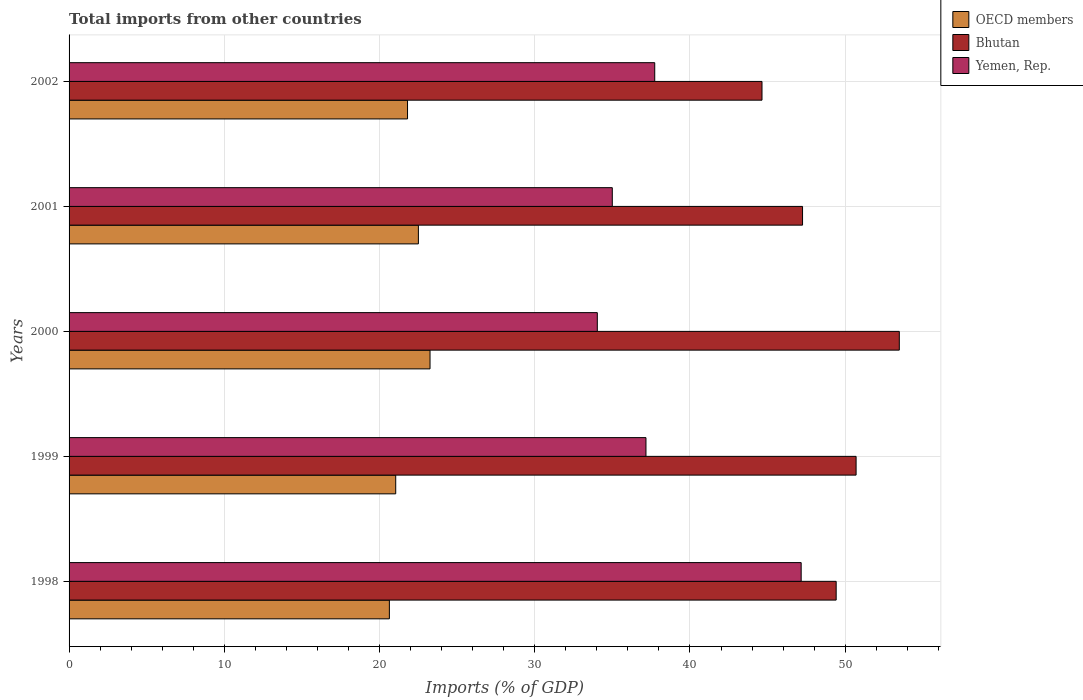Are the number of bars per tick equal to the number of legend labels?
Your answer should be very brief. Yes. How many bars are there on the 1st tick from the top?
Provide a succinct answer. 3. What is the label of the 4th group of bars from the top?
Offer a terse response. 1999. In how many cases, is the number of bars for a given year not equal to the number of legend labels?
Ensure brevity in your answer.  0. What is the total imports in OECD members in 1998?
Keep it short and to the point. 20.63. Across all years, what is the maximum total imports in Yemen, Rep.?
Your answer should be very brief. 47.16. Across all years, what is the minimum total imports in Bhutan?
Give a very brief answer. 44.64. In which year was the total imports in OECD members minimum?
Your answer should be very brief. 1998. What is the total total imports in OECD members in the graph?
Your response must be concise. 109.24. What is the difference between the total imports in OECD members in 1999 and that in 2001?
Make the answer very short. -1.46. What is the difference between the total imports in Bhutan in 1998 and the total imports in OECD members in 1999?
Offer a very short reply. 28.37. What is the average total imports in Yemen, Rep. per year?
Keep it short and to the point. 38.22. In the year 2001, what is the difference between the total imports in OECD members and total imports in Yemen, Rep.?
Your answer should be very brief. -12.49. What is the ratio of the total imports in Bhutan in 1999 to that in 2001?
Provide a short and direct response. 1.07. What is the difference between the highest and the second highest total imports in Bhutan?
Keep it short and to the point. 2.78. What is the difference between the highest and the lowest total imports in Bhutan?
Your answer should be very brief. 8.85. In how many years, is the total imports in Bhutan greater than the average total imports in Bhutan taken over all years?
Provide a succinct answer. 3. Is the sum of the total imports in Bhutan in 1998 and 1999 greater than the maximum total imports in Yemen, Rep. across all years?
Give a very brief answer. Yes. What does the 1st bar from the top in 1999 represents?
Provide a short and direct response. Yemen, Rep. What does the 2nd bar from the bottom in 2002 represents?
Your response must be concise. Bhutan. How many bars are there?
Your response must be concise. 15. Are all the bars in the graph horizontal?
Your response must be concise. Yes. How many years are there in the graph?
Offer a very short reply. 5. What is the difference between two consecutive major ticks on the X-axis?
Offer a terse response. 10. Does the graph contain any zero values?
Provide a succinct answer. No. Does the graph contain grids?
Offer a very short reply. Yes. How many legend labels are there?
Make the answer very short. 3. What is the title of the graph?
Provide a succinct answer. Total imports from other countries. What is the label or title of the X-axis?
Offer a terse response. Imports (% of GDP). What is the label or title of the Y-axis?
Offer a very short reply. Years. What is the Imports (% of GDP) of OECD members in 1998?
Provide a short and direct response. 20.63. What is the Imports (% of GDP) of Bhutan in 1998?
Give a very brief answer. 49.42. What is the Imports (% of GDP) of Yemen, Rep. in 1998?
Your response must be concise. 47.16. What is the Imports (% of GDP) of OECD members in 1999?
Make the answer very short. 21.04. What is the Imports (% of GDP) of Bhutan in 1999?
Make the answer very short. 50.7. What is the Imports (% of GDP) in Yemen, Rep. in 1999?
Make the answer very short. 37.16. What is the Imports (% of GDP) in OECD members in 2000?
Your answer should be very brief. 23.25. What is the Imports (% of GDP) of Bhutan in 2000?
Keep it short and to the point. 53.48. What is the Imports (% of GDP) in Yemen, Rep. in 2000?
Your answer should be very brief. 34.03. What is the Imports (% of GDP) of OECD members in 2001?
Provide a short and direct response. 22.5. What is the Imports (% of GDP) in Bhutan in 2001?
Make the answer very short. 47.25. What is the Imports (% of GDP) of Yemen, Rep. in 2001?
Your answer should be very brief. 35. What is the Imports (% of GDP) of OECD members in 2002?
Your response must be concise. 21.8. What is the Imports (% of GDP) of Bhutan in 2002?
Provide a short and direct response. 44.64. What is the Imports (% of GDP) in Yemen, Rep. in 2002?
Your answer should be very brief. 37.73. Across all years, what is the maximum Imports (% of GDP) in OECD members?
Provide a succinct answer. 23.25. Across all years, what is the maximum Imports (% of GDP) of Bhutan?
Your answer should be very brief. 53.48. Across all years, what is the maximum Imports (% of GDP) in Yemen, Rep.?
Provide a succinct answer. 47.16. Across all years, what is the minimum Imports (% of GDP) of OECD members?
Offer a very short reply. 20.63. Across all years, what is the minimum Imports (% of GDP) in Bhutan?
Provide a succinct answer. 44.64. Across all years, what is the minimum Imports (% of GDP) in Yemen, Rep.?
Make the answer very short. 34.03. What is the total Imports (% of GDP) in OECD members in the graph?
Your answer should be compact. 109.24. What is the total Imports (% of GDP) in Bhutan in the graph?
Make the answer very short. 245.49. What is the total Imports (% of GDP) in Yemen, Rep. in the graph?
Give a very brief answer. 191.08. What is the difference between the Imports (% of GDP) of OECD members in 1998 and that in 1999?
Your answer should be very brief. -0.41. What is the difference between the Imports (% of GDP) of Bhutan in 1998 and that in 1999?
Give a very brief answer. -1.28. What is the difference between the Imports (% of GDP) in Yemen, Rep. in 1998 and that in 1999?
Provide a succinct answer. 10. What is the difference between the Imports (% of GDP) of OECD members in 1998 and that in 2000?
Your response must be concise. -2.62. What is the difference between the Imports (% of GDP) of Bhutan in 1998 and that in 2000?
Your answer should be very brief. -4.07. What is the difference between the Imports (% of GDP) in Yemen, Rep. in 1998 and that in 2000?
Your response must be concise. 13.13. What is the difference between the Imports (% of GDP) of OECD members in 1998 and that in 2001?
Your answer should be compact. -1.87. What is the difference between the Imports (% of GDP) in Bhutan in 1998 and that in 2001?
Offer a terse response. 2.17. What is the difference between the Imports (% of GDP) of Yemen, Rep. in 1998 and that in 2001?
Make the answer very short. 12.17. What is the difference between the Imports (% of GDP) in OECD members in 1998 and that in 2002?
Make the answer very short. -1.17. What is the difference between the Imports (% of GDP) of Bhutan in 1998 and that in 2002?
Provide a succinct answer. 4.78. What is the difference between the Imports (% of GDP) of Yemen, Rep. in 1998 and that in 2002?
Offer a terse response. 9.43. What is the difference between the Imports (% of GDP) in OECD members in 1999 and that in 2000?
Your answer should be compact. -2.21. What is the difference between the Imports (% of GDP) of Bhutan in 1999 and that in 2000?
Offer a very short reply. -2.78. What is the difference between the Imports (% of GDP) of Yemen, Rep. in 1999 and that in 2000?
Your answer should be compact. 3.13. What is the difference between the Imports (% of GDP) of OECD members in 1999 and that in 2001?
Provide a succinct answer. -1.46. What is the difference between the Imports (% of GDP) of Bhutan in 1999 and that in 2001?
Ensure brevity in your answer.  3.45. What is the difference between the Imports (% of GDP) of Yemen, Rep. in 1999 and that in 2001?
Offer a terse response. 2.17. What is the difference between the Imports (% of GDP) in OECD members in 1999 and that in 2002?
Make the answer very short. -0.76. What is the difference between the Imports (% of GDP) in Bhutan in 1999 and that in 2002?
Provide a short and direct response. 6.06. What is the difference between the Imports (% of GDP) in Yemen, Rep. in 1999 and that in 2002?
Offer a terse response. -0.56. What is the difference between the Imports (% of GDP) of OECD members in 2000 and that in 2001?
Provide a succinct answer. 0.75. What is the difference between the Imports (% of GDP) of Bhutan in 2000 and that in 2001?
Offer a very short reply. 6.23. What is the difference between the Imports (% of GDP) of Yemen, Rep. in 2000 and that in 2001?
Provide a short and direct response. -0.97. What is the difference between the Imports (% of GDP) of OECD members in 2000 and that in 2002?
Give a very brief answer. 1.45. What is the difference between the Imports (% of GDP) of Bhutan in 2000 and that in 2002?
Ensure brevity in your answer.  8.85. What is the difference between the Imports (% of GDP) of Yemen, Rep. in 2000 and that in 2002?
Ensure brevity in your answer.  -3.7. What is the difference between the Imports (% of GDP) in OECD members in 2001 and that in 2002?
Make the answer very short. 0.7. What is the difference between the Imports (% of GDP) of Bhutan in 2001 and that in 2002?
Offer a terse response. 2.61. What is the difference between the Imports (% of GDP) of Yemen, Rep. in 2001 and that in 2002?
Ensure brevity in your answer.  -2.73. What is the difference between the Imports (% of GDP) of OECD members in 1998 and the Imports (% of GDP) of Bhutan in 1999?
Your answer should be compact. -30.07. What is the difference between the Imports (% of GDP) in OECD members in 1998 and the Imports (% of GDP) in Yemen, Rep. in 1999?
Ensure brevity in your answer.  -16.53. What is the difference between the Imports (% of GDP) in Bhutan in 1998 and the Imports (% of GDP) in Yemen, Rep. in 1999?
Your response must be concise. 12.25. What is the difference between the Imports (% of GDP) of OECD members in 1998 and the Imports (% of GDP) of Bhutan in 2000?
Keep it short and to the point. -32.85. What is the difference between the Imports (% of GDP) of OECD members in 1998 and the Imports (% of GDP) of Yemen, Rep. in 2000?
Ensure brevity in your answer.  -13.4. What is the difference between the Imports (% of GDP) in Bhutan in 1998 and the Imports (% of GDP) in Yemen, Rep. in 2000?
Your answer should be compact. 15.39. What is the difference between the Imports (% of GDP) in OECD members in 1998 and the Imports (% of GDP) in Bhutan in 2001?
Offer a very short reply. -26.62. What is the difference between the Imports (% of GDP) in OECD members in 1998 and the Imports (% of GDP) in Yemen, Rep. in 2001?
Offer a very short reply. -14.36. What is the difference between the Imports (% of GDP) in Bhutan in 1998 and the Imports (% of GDP) in Yemen, Rep. in 2001?
Your response must be concise. 14.42. What is the difference between the Imports (% of GDP) of OECD members in 1998 and the Imports (% of GDP) of Bhutan in 2002?
Offer a terse response. -24. What is the difference between the Imports (% of GDP) of OECD members in 1998 and the Imports (% of GDP) of Yemen, Rep. in 2002?
Provide a succinct answer. -17.09. What is the difference between the Imports (% of GDP) of Bhutan in 1998 and the Imports (% of GDP) of Yemen, Rep. in 2002?
Make the answer very short. 11.69. What is the difference between the Imports (% of GDP) of OECD members in 1999 and the Imports (% of GDP) of Bhutan in 2000?
Ensure brevity in your answer.  -32.44. What is the difference between the Imports (% of GDP) of OECD members in 1999 and the Imports (% of GDP) of Yemen, Rep. in 2000?
Offer a very short reply. -12.99. What is the difference between the Imports (% of GDP) of Bhutan in 1999 and the Imports (% of GDP) of Yemen, Rep. in 2000?
Your answer should be very brief. 16.67. What is the difference between the Imports (% of GDP) in OECD members in 1999 and the Imports (% of GDP) in Bhutan in 2001?
Make the answer very short. -26.21. What is the difference between the Imports (% of GDP) of OECD members in 1999 and the Imports (% of GDP) of Yemen, Rep. in 2001?
Your answer should be very brief. -13.95. What is the difference between the Imports (% of GDP) of Bhutan in 1999 and the Imports (% of GDP) of Yemen, Rep. in 2001?
Your response must be concise. 15.71. What is the difference between the Imports (% of GDP) in OECD members in 1999 and the Imports (% of GDP) in Bhutan in 2002?
Ensure brevity in your answer.  -23.6. What is the difference between the Imports (% of GDP) of OECD members in 1999 and the Imports (% of GDP) of Yemen, Rep. in 2002?
Give a very brief answer. -16.69. What is the difference between the Imports (% of GDP) in Bhutan in 1999 and the Imports (% of GDP) in Yemen, Rep. in 2002?
Your response must be concise. 12.97. What is the difference between the Imports (% of GDP) of OECD members in 2000 and the Imports (% of GDP) of Bhutan in 2001?
Your response must be concise. -24. What is the difference between the Imports (% of GDP) of OECD members in 2000 and the Imports (% of GDP) of Yemen, Rep. in 2001?
Keep it short and to the point. -11.74. What is the difference between the Imports (% of GDP) in Bhutan in 2000 and the Imports (% of GDP) in Yemen, Rep. in 2001?
Your response must be concise. 18.49. What is the difference between the Imports (% of GDP) in OECD members in 2000 and the Imports (% of GDP) in Bhutan in 2002?
Ensure brevity in your answer.  -21.39. What is the difference between the Imports (% of GDP) of OECD members in 2000 and the Imports (% of GDP) of Yemen, Rep. in 2002?
Your answer should be very brief. -14.48. What is the difference between the Imports (% of GDP) of Bhutan in 2000 and the Imports (% of GDP) of Yemen, Rep. in 2002?
Offer a terse response. 15.76. What is the difference between the Imports (% of GDP) in OECD members in 2001 and the Imports (% of GDP) in Bhutan in 2002?
Keep it short and to the point. -22.14. What is the difference between the Imports (% of GDP) in OECD members in 2001 and the Imports (% of GDP) in Yemen, Rep. in 2002?
Offer a terse response. -15.23. What is the difference between the Imports (% of GDP) of Bhutan in 2001 and the Imports (% of GDP) of Yemen, Rep. in 2002?
Make the answer very short. 9.52. What is the average Imports (% of GDP) of OECD members per year?
Offer a very short reply. 21.85. What is the average Imports (% of GDP) of Bhutan per year?
Your answer should be compact. 49.1. What is the average Imports (% of GDP) of Yemen, Rep. per year?
Give a very brief answer. 38.22. In the year 1998, what is the difference between the Imports (% of GDP) in OECD members and Imports (% of GDP) in Bhutan?
Provide a succinct answer. -28.78. In the year 1998, what is the difference between the Imports (% of GDP) of OECD members and Imports (% of GDP) of Yemen, Rep.?
Offer a terse response. -26.53. In the year 1998, what is the difference between the Imports (% of GDP) of Bhutan and Imports (% of GDP) of Yemen, Rep.?
Provide a succinct answer. 2.26. In the year 1999, what is the difference between the Imports (% of GDP) in OECD members and Imports (% of GDP) in Bhutan?
Give a very brief answer. -29.66. In the year 1999, what is the difference between the Imports (% of GDP) of OECD members and Imports (% of GDP) of Yemen, Rep.?
Keep it short and to the point. -16.12. In the year 1999, what is the difference between the Imports (% of GDP) of Bhutan and Imports (% of GDP) of Yemen, Rep.?
Your answer should be compact. 13.54. In the year 2000, what is the difference between the Imports (% of GDP) of OECD members and Imports (% of GDP) of Bhutan?
Keep it short and to the point. -30.23. In the year 2000, what is the difference between the Imports (% of GDP) in OECD members and Imports (% of GDP) in Yemen, Rep.?
Offer a very short reply. -10.78. In the year 2000, what is the difference between the Imports (% of GDP) in Bhutan and Imports (% of GDP) in Yemen, Rep.?
Offer a very short reply. 19.45. In the year 2001, what is the difference between the Imports (% of GDP) in OECD members and Imports (% of GDP) in Bhutan?
Offer a terse response. -24.75. In the year 2001, what is the difference between the Imports (% of GDP) in OECD members and Imports (% of GDP) in Yemen, Rep.?
Your answer should be compact. -12.49. In the year 2001, what is the difference between the Imports (% of GDP) in Bhutan and Imports (% of GDP) in Yemen, Rep.?
Make the answer very short. 12.26. In the year 2002, what is the difference between the Imports (% of GDP) in OECD members and Imports (% of GDP) in Bhutan?
Provide a succinct answer. -22.84. In the year 2002, what is the difference between the Imports (% of GDP) of OECD members and Imports (% of GDP) of Yemen, Rep.?
Offer a terse response. -15.93. In the year 2002, what is the difference between the Imports (% of GDP) of Bhutan and Imports (% of GDP) of Yemen, Rep.?
Your answer should be very brief. 6.91. What is the ratio of the Imports (% of GDP) in OECD members in 1998 to that in 1999?
Keep it short and to the point. 0.98. What is the ratio of the Imports (% of GDP) of Bhutan in 1998 to that in 1999?
Your answer should be compact. 0.97. What is the ratio of the Imports (% of GDP) of Yemen, Rep. in 1998 to that in 1999?
Provide a short and direct response. 1.27. What is the ratio of the Imports (% of GDP) of OECD members in 1998 to that in 2000?
Offer a very short reply. 0.89. What is the ratio of the Imports (% of GDP) of Bhutan in 1998 to that in 2000?
Provide a short and direct response. 0.92. What is the ratio of the Imports (% of GDP) of Yemen, Rep. in 1998 to that in 2000?
Make the answer very short. 1.39. What is the ratio of the Imports (% of GDP) in OECD members in 1998 to that in 2001?
Keep it short and to the point. 0.92. What is the ratio of the Imports (% of GDP) in Bhutan in 1998 to that in 2001?
Provide a succinct answer. 1.05. What is the ratio of the Imports (% of GDP) in Yemen, Rep. in 1998 to that in 2001?
Your answer should be very brief. 1.35. What is the ratio of the Imports (% of GDP) in OECD members in 1998 to that in 2002?
Your answer should be compact. 0.95. What is the ratio of the Imports (% of GDP) of Bhutan in 1998 to that in 2002?
Offer a very short reply. 1.11. What is the ratio of the Imports (% of GDP) of Yemen, Rep. in 1998 to that in 2002?
Provide a short and direct response. 1.25. What is the ratio of the Imports (% of GDP) in OECD members in 1999 to that in 2000?
Give a very brief answer. 0.91. What is the ratio of the Imports (% of GDP) in Bhutan in 1999 to that in 2000?
Give a very brief answer. 0.95. What is the ratio of the Imports (% of GDP) of Yemen, Rep. in 1999 to that in 2000?
Offer a terse response. 1.09. What is the ratio of the Imports (% of GDP) of OECD members in 1999 to that in 2001?
Your response must be concise. 0.94. What is the ratio of the Imports (% of GDP) in Bhutan in 1999 to that in 2001?
Your response must be concise. 1.07. What is the ratio of the Imports (% of GDP) in Yemen, Rep. in 1999 to that in 2001?
Provide a succinct answer. 1.06. What is the ratio of the Imports (% of GDP) of OECD members in 1999 to that in 2002?
Offer a very short reply. 0.97. What is the ratio of the Imports (% of GDP) in Bhutan in 1999 to that in 2002?
Keep it short and to the point. 1.14. What is the ratio of the Imports (% of GDP) of Yemen, Rep. in 1999 to that in 2002?
Make the answer very short. 0.98. What is the ratio of the Imports (% of GDP) of OECD members in 2000 to that in 2001?
Your answer should be compact. 1.03. What is the ratio of the Imports (% of GDP) of Bhutan in 2000 to that in 2001?
Ensure brevity in your answer.  1.13. What is the ratio of the Imports (% of GDP) of Yemen, Rep. in 2000 to that in 2001?
Ensure brevity in your answer.  0.97. What is the ratio of the Imports (% of GDP) of OECD members in 2000 to that in 2002?
Your response must be concise. 1.07. What is the ratio of the Imports (% of GDP) of Bhutan in 2000 to that in 2002?
Offer a very short reply. 1.2. What is the ratio of the Imports (% of GDP) of Yemen, Rep. in 2000 to that in 2002?
Your answer should be compact. 0.9. What is the ratio of the Imports (% of GDP) of OECD members in 2001 to that in 2002?
Your response must be concise. 1.03. What is the ratio of the Imports (% of GDP) of Bhutan in 2001 to that in 2002?
Make the answer very short. 1.06. What is the ratio of the Imports (% of GDP) in Yemen, Rep. in 2001 to that in 2002?
Make the answer very short. 0.93. What is the difference between the highest and the second highest Imports (% of GDP) of OECD members?
Provide a succinct answer. 0.75. What is the difference between the highest and the second highest Imports (% of GDP) of Bhutan?
Provide a short and direct response. 2.78. What is the difference between the highest and the second highest Imports (% of GDP) of Yemen, Rep.?
Offer a very short reply. 9.43. What is the difference between the highest and the lowest Imports (% of GDP) in OECD members?
Provide a succinct answer. 2.62. What is the difference between the highest and the lowest Imports (% of GDP) of Bhutan?
Give a very brief answer. 8.85. What is the difference between the highest and the lowest Imports (% of GDP) in Yemen, Rep.?
Your answer should be compact. 13.13. 